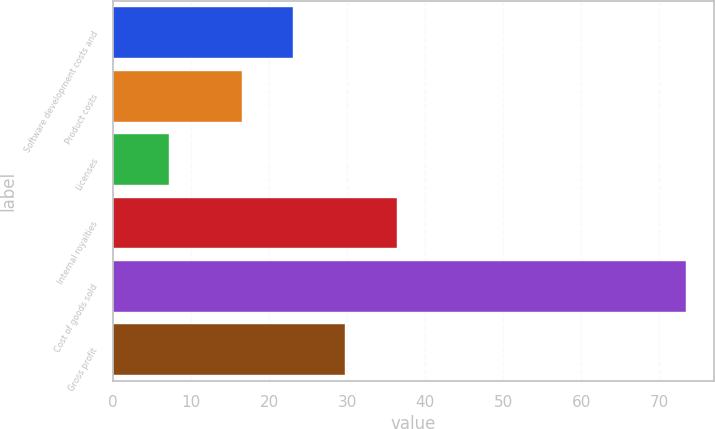Convert chart. <chart><loc_0><loc_0><loc_500><loc_500><bar_chart><fcel>Software development costs and<fcel>Product costs<fcel>Licenses<fcel>Internal royalties<fcel>Cost of goods sold<fcel>Gross profit<nl><fcel>23.12<fcel>16.5<fcel>7.2<fcel>36.36<fcel>73.4<fcel>29.74<nl></chart> 